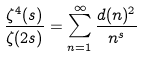Convert formula to latex. <formula><loc_0><loc_0><loc_500><loc_500>\frac { \zeta ^ { 4 } ( s ) } { \zeta ( 2 s ) } = \sum _ { n = 1 } ^ { \infty } \frac { d ( n ) ^ { 2 } } { n ^ { s } }</formula> 